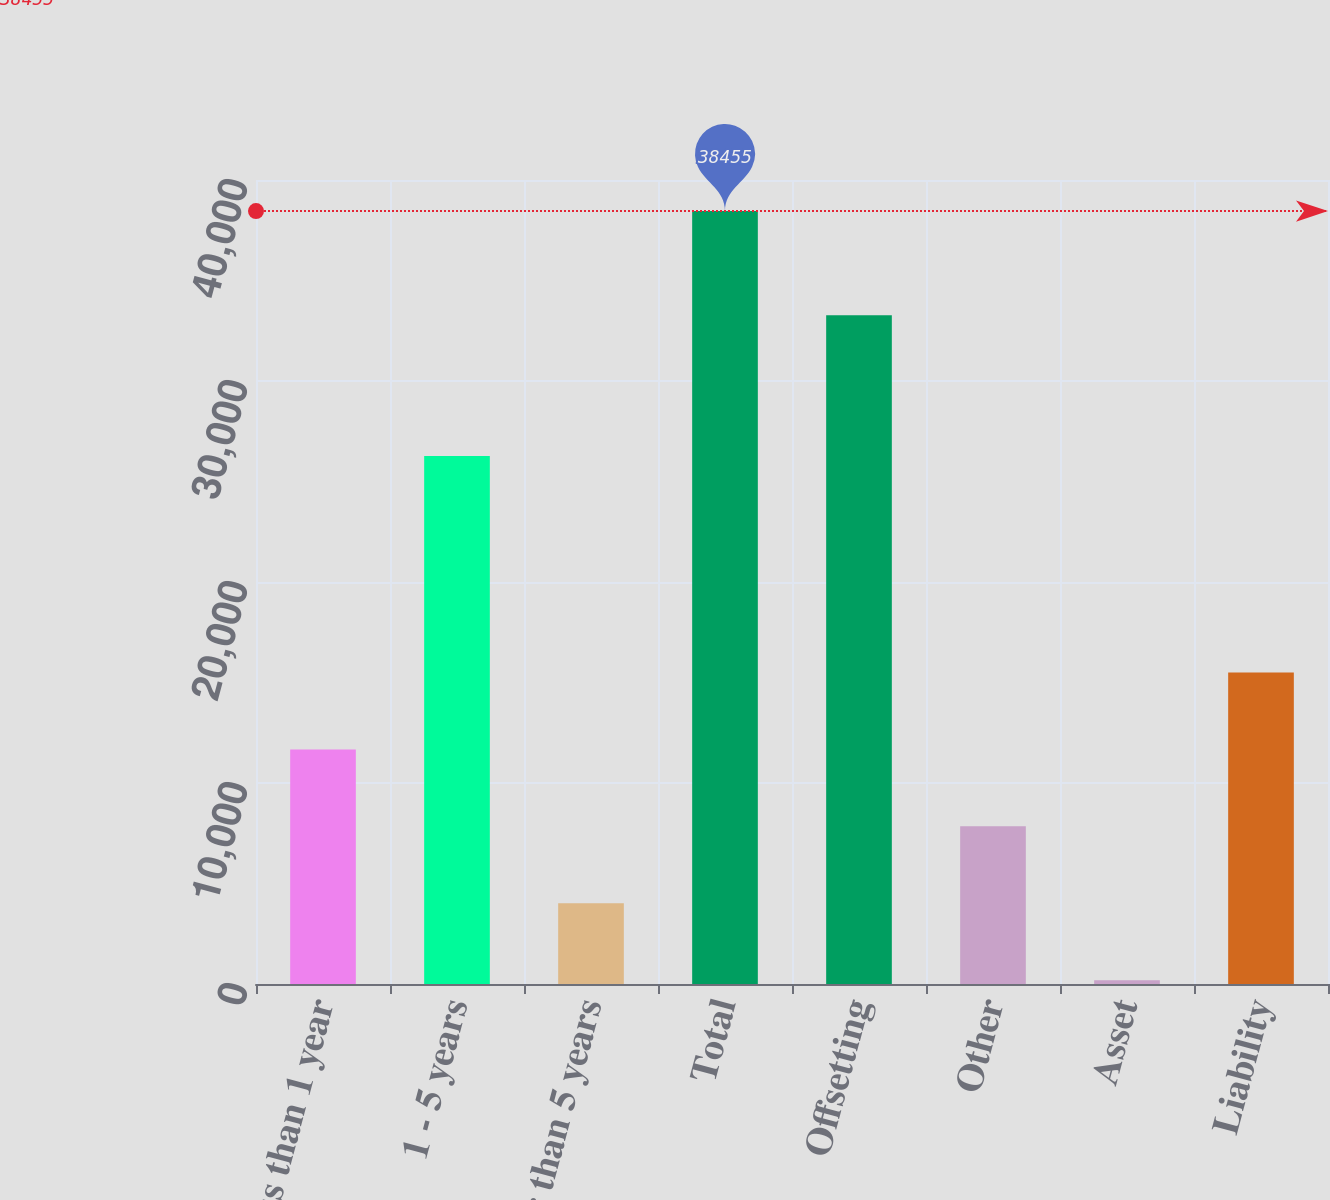<chart> <loc_0><loc_0><loc_500><loc_500><bar_chart><fcel>Less than 1 year<fcel>1 - 5 years<fcel>Greater than 5 years<fcel>Total<fcel>Offsetting<fcel>Other<fcel>Asset<fcel>Liability<nl><fcel>11669.5<fcel>26271<fcel>4016.5<fcel>38455<fcel>33266<fcel>7843<fcel>190<fcel>15496<nl></chart> 